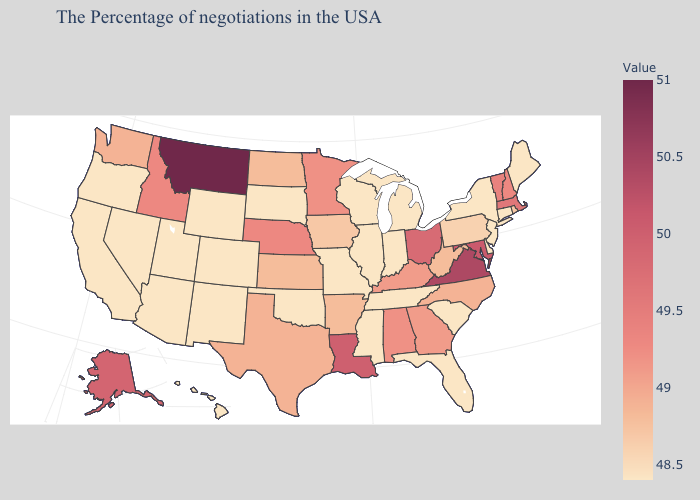Does Delaware have the lowest value in the South?
Concise answer only. Yes. Among the states that border Texas , does New Mexico have the lowest value?
Keep it brief. Yes. Among the states that border Kentucky , which have the highest value?
Be succinct. Virginia. Which states hav the highest value in the MidWest?
Answer briefly. Ohio. Which states have the highest value in the USA?
Concise answer only. Montana. 